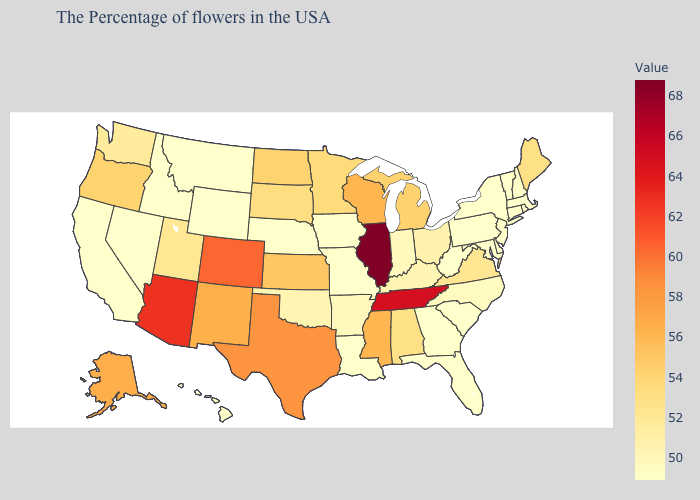Does Ohio have the lowest value in the USA?
Give a very brief answer. No. Among the states that border Wyoming , does Colorado have the highest value?
Concise answer only. Yes. Which states hav the highest value in the South?
Be succinct. Tennessee. Which states have the highest value in the USA?
Give a very brief answer. Illinois. Is the legend a continuous bar?
Short answer required. Yes. Does North Dakota have the highest value in the USA?
Give a very brief answer. No. 